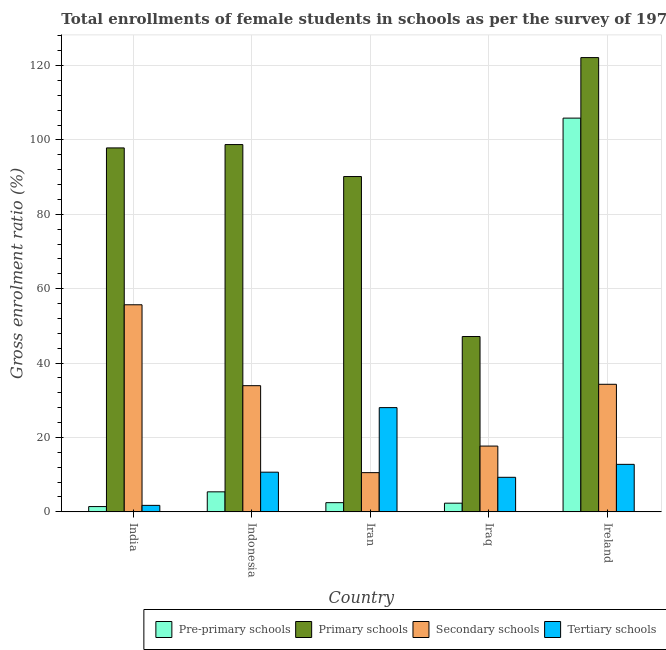How many different coloured bars are there?
Provide a short and direct response. 4. How many groups of bars are there?
Give a very brief answer. 5. Are the number of bars per tick equal to the number of legend labels?
Ensure brevity in your answer.  Yes. How many bars are there on the 2nd tick from the left?
Your response must be concise. 4. How many bars are there on the 2nd tick from the right?
Your answer should be compact. 4. What is the label of the 5th group of bars from the left?
Offer a very short reply. Ireland. What is the gross enrolment ratio(female) in tertiary schools in India?
Provide a short and direct response. 1.75. Across all countries, what is the maximum gross enrolment ratio(female) in primary schools?
Make the answer very short. 122.12. Across all countries, what is the minimum gross enrolment ratio(female) in primary schools?
Offer a terse response. 47.14. In which country was the gross enrolment ratio(female) in primary schools minimum?
Offer a very short reply. Iraq. What is the total gross enrolment ratio(female) in secondary schools in the graph?
Offer a very short reply. 152.13. What is the difference between the gross enrolment ratio(female) in secondary schools in Iran and that in Ireland?
Your answer should be very brief. -23.75. What is the difference between the gross enrolment ratio(female) in pre-primary schools in Iraq and the gross enrolment ratio(female) in primary schools in Ireland?
Your answer should be very brief. -119.78. What is the average gross enrolment ratio(female) in primary schools per country?
Offer a very short reply. 91.2. What is the difference between the gross enrolment ratio(female) in tertiary schools and gross enrolment ratio(female) in primary schools in India?
Provide a succinct answer. -96.09. What is the ratio of the gross enrolment ratio(female) in primary schools in India to that in Indonesia?
Give a very brief answer. 0.99. Is the gross enrolment ratio(female) in secondary schools in India less than that in Iraq?
Your answer should be very brief. No. Is the difference between the gross enrolment ratio(female) in pre-primary schools in India and Iran greater than the difference between the gross enrolment ratio(female) in primary schools in India and Iran?
Ensure brevity in your answer.  No. What is the difference between the highest and the second highest gross enrolment ratio(female) in primary schools?
Ensure brevity in your answer.  23.38. What is the difference between the highest and the lowest gross enrolment ratio(female) in primary schools?
Ensure brevity in your answer.  74.98. In how many countries, is the gross enrolment ratio(female) in secondary schools greater than the average gross enrolment ratio(female) in secondary schools taken over all countries?
Offer a very short reply. 3. Is the sum of the gross enrolment ratio(female) in tertiary schools in India and Iraq greater than the maximum gross enrolment ratio(female) in pre-primary schools across all countries?
Your answer should be compact. No. Is it the case that in every country, the sum of the gross enrolment ratio(female) in tertiary schools and gross enrolment ratio(female) in primary schools is greater than the sum of gross enrolment ratio(female) in secondary schools and gross enrolment ratio(female) in pre-primary schools?
Make the answer very short. No. What does the 2nd bar from the left in India represents?
Provide a short and direct response. Primary schools. What does the 2nd bar from the right in Indonesia represents?
Make the answer very short. Secondary schools. What is the difference between two consecutive major ticks on the Y-axis?
Offer a very short reply. 20. Are the values on the major ticks of Y-axis written in scientific E-notation?
Your answer should be very brief. No. Does the graph contain any zero values?
Provide a succinct answer. No. Does the graph contain grids?
Provide a succinct answer. Yes. Where does the legend appear in the graph?
Provide a succinct answer. Bottom right. How are the legend labels stacked?
Your answer should be compact. Horizontal. What is the title of the graph?
Ensure brevity in your answer.  Total enrollments of female students in schools as per the survey of 1973 conducted in different countries. What is the label or title of the X-axis?
Make the answer very short. Country. What is the label or title of the Y-axis?
Your answer should be compact. Gross enrolment ratio (%). What is the Gross enrolment ratio (%) of Pre-primary schools in India?
Keep it short and to the point. 1.43. What is the Gross enrolment ratio (%) of Primary schools in India?
Provide a succinct answer. 97.84. What is the Gross enrolment ratio (%) of Secondary schools in India?
Offer a terse response. 55.67. What is the Gross enrolment ratio (%) of Tertiary schools in India?
Provide a succinct answer. 1.75. What is the Gross enrolment ratio (%) in Pre-primary schools in Indonesia?
Ensure brevity in your answer.  5.39. What is the Gross enrolment ratio (%) in Primary schools in Indonesia?
Keep it short and to the point. 98.74. What is the Gross enrolment ratio (%) in Secondary schools in Indonesia?
Provide a succinct answer. 33.92. What is the Gross enrolment ratio (%) in Tertiary schools in Indonesia?
Your answer should be very brief. 10.67. What is the Gross enrolment ratio (%) in Pre-primary schools in Iran?
Ensure brevity in your answer.  2.48. What is the Gross enrolment ratio (%) of Primary schools in Iran?
Keep it short and to the point. 90.15. What is the Gross enrolment ratio (%) in Secondary schools in Iran?
Provide a succinct answer. 10.55. What is the Gross enrolment ratio (%) in Tertiary schools in Iran?
Provide a short and direct response. 28.03. What is the Gross enrolment ratio (%) in Pre-primary schools in Iraq?
Your answer should be very brief. 2.34. What is the Gross enrolment ratio (%) in Primary schools in Iraq?
Offer a very short reply. 47.14. What is the Gross enrolment ratio (%) in Secondary schools in Iraq?
Your response must be concise. 17.69. What is the Gross enrolment ratio (%) in Tertiary schools in Iraq?
Offer a terse response. 9.29. What is the Gross enrolment ratio (%) in Pre-primary schools in Ireland?
Your answer should be compact. 105.85. What is the Gross enrolment ratio (%) of Primary schools in Ireland?
Your answer should be compact. 122.12. What is the Gross enrolment ratio (%) of Secondary schools in Ireland?
Offer a very short reply. 34.3. What is the Gross enrolment ratio (%) in Tertiary schools in Ireland?
Your answer should be very brief. 12.77. Across all countries, what is the maximum Gross enrolment ratio (%) of Pre-primary schools?
Your answer should be very brief. 105.85. Across all countries, what is the maximum Gross enrolment ratio (%) of Primary schools?
Offer a terse response. 122.12. Across all countries, what is the maximum Gross enrolment ratio (%) in Secondary schools?
Ensure brevity in your answer.  55.67. Across all countries, what is the maximum Gross enrolment ratio (%) of Tertiary schools?
Provide a short and direct response. 28.03. Across all countries, what is the minimum Gross enrolment ratio (%) in Pre-primary schools?
Make the answer very short. 1.43. Across all countries, what is the minimum Gross enrolment ratio (%) of Primary schools?
Provide a short and direct response. 47.14. Across all countries, what is the minimum Gross enrolment ratio (%) of Secondary schools?
Your answer should be compact. 10.55. Across all countries, what is the minimum Gross enrolment ratio (%) of Tertiary schools?
Provide a short and direct response. 1.75. What is the total Gross enrolment ratio (%) in Pre-primary schools in the graph?
Provide a succinct answer. 117.48. What is the total Gross enrolment ratio (%) of Primary schools in the graph?
Ensure brevity in your answer.  455.99. What is the total Gross enrolment ratio (%) of Secondary schools in the graph?
Your response must be concise. 152.13. What is the total Gross enrolment ratio (%) in Tertiary schools in the graph?
Give a very brief answer. 62.51. What is the difference between the Gross enrolment ratio (%) in Pre-primary schools in India and that in Indonesia?
Your response must be concise. -3.96. What is the difference between the Gross enrolment ratio (%) in Primary schools in India and that in Indonesia?
Your response must be concise. -0.9. What is the difference between the Gross enrolment ratio (%) in Secondary schools in India and that in Indonesia?
Offer a terse response. 21.75. What is the difference between the Gross enrolment ratio (%) of Tertiary schools in India and that in Indonesia?
Your answer should be compact. -8.92. What is the difference between the Gross enrolment ratio (%) in Pre-primary schools in India and that in Iran?
Offer a very short reply. -1.05. What is the difference between the Gross enrolment ratio (%) of Primary schools in India and that in Iran?
Your response must be concise. 7.7. What is the difference between the Gross enrolment ratio (%) of Secondary schools in India and that in Iran?
Your answer should be very brief. 45.13. What is the difference between the Gross enrolment ratio (%) of Tertiary schools in India and that in Iran?
Ensure brevity in your answer.  -26.28. What is the difference between the Gross enrolment ratio (%) in Pre-primary schools in India and that in Iraq?
Offer a very short reply. -0.91. What is the difference between the Gross enrolment ratio (%) in Primary schools in India and that in Iraq?
Your response must be concise. 50.7. What is the difference between the Gross enrolment ratio (%) of Secondary schools in India and that in Iraq?
Your response must be concise. 37.99. What is the difference between the Gross enrolment ratio (%) in Tertiary schools in India and that in Iraq?
Offer a very short reply. -7.54. What is the difference between the Gross enrolment ratio (%) in Pre-primary schools in India and that in Ireland?
Provide a short and direct response. -104.42. What is the difference between the Gross enrolment ratio (%) of Primary schools in India and that in Ireland?
Ensure brevity in your answer.  -24.28. What is the difference between the Gross enrolment ratio (%) in Secondary schools in India and that in Ireland?
Keep it short and to the point. 21.38. What is the difference between the Gross enrolment ratio (%) in Tertiary schools in India and that in Ireland?
Your response must be concise. -11.02. What is the difference between the Gross enrolment ratio (%) of Pre-primary schools in Indonesia and that in Iran?
Make the answer very short. 2.91. What is the difference between the Gross enrolment ratio (%) of Primary schools in Indonesia and that in Iran?
Provide a short and direct response. 8.59. What is the difference between the Gross enrolment ratio (%) of Secondary schools in Indonesia and that in Iran?
Keep it short and to the point. 23.38. What is the difference between the Gross enrolment ratio (%) in Tertiary schools in Indonesia and that in Iran?
Offer a terse response. -17.36. What is the difference between the Gross enrolment ratio (%) in Pre-primary schools in Indonesia and that in Iraq?
Make the answer very short. 3.05. What is the difference between the Gross enrolment ratio (%) of Primary schools in Indonesia and that in Iraq?
Offer a very short reply. 51.6. What is the difference between the Gross enrolment ratio (%) of Secondary schools in Indonesia and that in Iraq?
Give a very brief answer. 16.23. What is the difference between the Gross enrolment ratio (%) of Tertiary schools in Indonesia and that in Iraq?
Provide a short and direct response. 1.38. What is the difference between the Gross enrolment ratio (%) of Pre-primary schools in Indonesia and that in Ireland?
Provide a succinct answer. -100.46. What is the difference between the Gross enrolment ratio (%) of Primary schools in Indonesia and that in Ireland?
Your response must be concise. -23.38. What is the difference between the Gross enrolment ratio (%) in Secondary schools in Indonesia and that in Ireland?
Your answer should be compact. -0.38. What is the difference between the Gross enrolment ratio (%) of Tertiary schools in Indonesia and that in Ireland?
Your answer should be very brief. -2.11. What is the difference between the Gross enrolment ratio (%) of Pre-primary schools in Iran and that in Iraq?
Make the answer very short. 0.14. What is the difference between the Gross enrolment ratio (%) of Primary schools in Iran and that in Iraq?
Make the answer very short. 43.01. What is the difference between the Gross enrolment ratio (%) of Secondary schools in Iran and that in Iraq?
Your response must be concise. -7.14. What is the difference between the Gross enrolment ratio (%) in Tertiary schools in Iran and that in Iraq?
Your response must be concise. 18.73. What is the difference between the Gross enrolment ratio (%) in Pre-primary schools in Iran and that in Ireland?
Ensure brevity in your answer.  -103.37. What is the difference between the Gross enrolment ratio (%) in Primary schools in Iran and that in Ireland?
Offer a very short reply. -31.98. What is the difference between the Gross enrolment ratio (%) of Secondary schools in Iran and that in Ireland?
Your answer should be compact. -23.75. What is the difference between the Gross enrolment ratio (%) in Tertiary schools in Iran and that in Ireland?
Your response must be concise. 15.25. What is the difference between the Gross enrolment ratio (%) in Pre-primary schools in Iraq and that in Ireland?
Offer a very short reply. -103.51. What is the difference between the Gross enrolment ratio (%) of Primary schools in Iraq and that in Ireland?
Ensure brevity in your answer.  -74.98. What is the difference between the Gross enrolment ratio (%) of Secondary schools in Iraq and that in Ireland?
Your response must be concise. -16.61. What is the difference between the Gross enrolment ratio (%) of Tertiary schools in Iraq and that in Ireland?
Make the answer very short. -3.48. What is the difference between the Gross enrolment ratio (%) of Pre-primary schools in India and the Gross enrolment ratio (%) of Primary schools in Indonesia?
Your answer should be very brief. -97.31. What is the difference between the Gross enrolment ratio (%) of Pre-primary schools in India and the Gross enrolment ratio (%) of Secondary schools in Indonesia?
Make the answer very short. -32.5. What is the difference between the Gross enrolment ratio (%) of Pre-primary schools in India and the Gross enrolment ratio (%) of Tertiary schools in Indonesia?
Make the answer very short. -9.24. What is the difference between the Gross enrolment ratio (%) in Primary schools in India and the Gross enrolment ratio (%) in Secondary schools in Indonesia?
Offer a very short reply. 63.92. What is the difference between the Gross enrolment ratio (%) of Primary schools in India and the Gross enrolment ratio (%) of Tertiary schools in Indonesia?
Your response must be concise. 87.17. What is the difference between the Gross enrolment ratio (%) of Secondary schools in India and the Gross enrolment ratio (%) of Tertiary schools in Indonesia?
Your answer should be compact. 45. What is the difference between the Gross enrolment ratio (%) of Pre-primary schools in India and the Gross enrolment ratio (%) of Primary schools in Iran?
Provide a succinct answer. -88.72. What is the difference between the Gross enrolment ratio (%) in Pre-primary schools in India and the Gross enrolment ratio (%) in Secondary schools in Iran?
Your answer should be compact. -9.12. What is the difference between the Gross enrolment ratio (%) of Pre-primary schools in India and the Gross enrolment ratio (%) of Tertiary schools in Iran?
Give a very brief answer. -26.6. What is the difference between the Gross enrolment ratio (%) of Primary schools in India and the Gross enrolment ratio (%) of Secondary schools in Iran?
Your answer should be very brief. 87.3. What is the difference between the Gross enrolment ratio (%) of Primary schools in India and the Gross enrolment ratio (%) of Tertiary schools in Iran?
Offer a very short reply. 69.82. What is the difference between the Gross enrolment ratio (%) in Secondary schools in India and the Gross enrolment ratio (%) in Tertiary schools in Iran?
Provide a succinct answer. 27.65. What is the difference between the Gross enrolment ratio (%) of Pre-primary schools in India and the Gross enrolment ratio (%) of Primary schools in Iraq?
Your response must be concise. -45.71. What is the difference between the Gross enrolment ratio (%) of Pre-primary schools in India and the Gross enrolment ratio (%) of Secondary schools in Iraq?
Keep it short and to the point. -16.26. What is the difference between the Gross enrolment ratio (%) of Pre-primary schools in India and the Gross enrolment ratio (%) of Tertiary schools in Iraq?
Keep it short and to the point. -7.87. What is the difference between the Gross enrolment ratio (%) in Primary schools in India and the Gross enrolment ratio (%) in Secondary schools in Iraq?
Provide a short and direct response. 80.16. What is the difference between the Gross enrolment ratio (%) in Primary schools in India and the Gross enrolment ratio (%) in Tertiary schools in Iraq?
Your answer should be very brief. 88.55. What is the difference between the Gross enrolment ratio (%) in Secondary schools in India and the Gross enrolment ratio (%) in Tertiary schools in Iraq?
Your answer should be very brief. 46.38. What is the difference between the Gross enrolment ratio (%) in Pre-primary schools in India and the Gross enrolment ratio (%) in Primary schools in Ireland?
Offer a very short reply. -120.7. What is the difference between the Gross enrolment ratio (%) in Pre-primary schools in India and the Gross enrolment ratio (%) in Secondary schools in Ireland?
Your answer should be very brief. -32.87. What is the difference between the Gross enrolment ratio (%) of Pre-primary schools in India and the Gross enrolment ratio (%) of Tertiary schools in Ireland?
Your response must be concise. -11.35. What is the difference between the Gross enrolment ratio (%) of Primary schools in India and the Gross enrolment ratio (%) of Secondary schools in Ireland?
Offer a very short reply. 63.55. What is the difference between the Gross enrolment ratio (%) in Primary schools in India and the Gross enrolment ratio (%) in Tertiary schools in Ireland?
Provide a succinct answer. 85.07. What is the difference between the Gross enrolment ratio (%) in Secondary schools in India and the Gross enrolment ratio (%) in Tertiary schools in Ireland?
Offer a very short reply. 42.9. What is the difference between the Gross enrolment ratio (%) in Pre-primary schools in Indonesia and the Gross enrolment ratio (%) in Primary schools in Iran?
Make the answer very short. -84.76. What is the difference between the Gross enrolment ratio (%) of Pre-primary schools in Indonesia and the Gross enrolment ratio (%) of Secondary schools in Iran?
Offer a terse response. -5.16. What is the difference between the Gross enrolment ratio (%) of Pre-primary schools in Indonesia and the Gross enrolment ratio (%) of Tertiary schools in Iran?
Ensure brevity in your answer.  -22.64. What is the difference between the Gross enrolment ratio (%) of Primary schools in Indonesia and the Gross enrolment ratio (%) of Secondary schools in Iran?
Your answer should be compact. 88.19. What is the difference between the Gross enrolment ratio (%) in Primary schools in Indonesia and the Gross enrolment ratio (%) in Tertiary schools in Iran?
Keep it short and to the point. 70.71. What is the difference between the Gross enrolment ratio (%) in Secondary schools in Indonesia and the Gross enrolment ratio (%) in Tertiary schools in Iran?
Your response must be concise. 5.9. What is the difference between the Gross enrolment ratio (%) in Pre-primary schools in Indonesia and the Gross enrolment ratio (%) in Primary schools in Iraq?
Offer a terse response. -41.75. What is the difference between the Gross enrolment ratio (%) of Pre-primary schools in Indonesia and the Gross enrolment ratio (%) of Secondary schools in Iraq?
Your response must be concise. -12.3. What is the difference between the Gross enrolment ratio (%) in Pre-primary schools in Indonesia and the Gross enrolment ratio (%) in Tertiary schools in Iraq?
Provide a succinct answer. -3.9. What is the difference between the Gross enrolment ratio (%) of Primary schools in Indonesia and the Gross enrolment ratio (%) of Secondary schools in Iraq?
Provide a succinct answer. 81.05. What is the difference between the Gross enrolment ratio (%) of Primary schools in Indonesia and the Gross enrolment ratio (%) of Tertiary schools in Iraq?
Ensure brevity in your answer.  89.45. What is the difference between the Gross enrolment ratio (%) in Secondary schools in Indonesia and the Gross enrolment ratio (%) in Tertiary schools in Iraq?
Provide a succinct answer. 24.63. What is the difference between the Gross enrolment ratio (%) of Pre-primary schools in Indonesia and the Gross enrolment ratio (%) of Primary schools in Ireland?
Provide a succinct answer. -116.74. What is the difference between the Gross enrolment ratio (%) of Pre-primary schools in Indonesia and the Gross enrolment ratio (%) of Secondary schools in Ireland?
Provide a succinct answer. -28.91. What is the difference between the Gross enrolment ratio (%) of Pre-primary schools in Indonesia and the Gross enrolment ratio (%) of Tertiary schools in Ireland?
Your answer should be very brief. -7.39. What is the difference between the Gross enrolment ratio (%) in Primary schools in Indonesia and the Gross enrolment ratio (%) in Secondary schools in Ireland?
Offer a terse response. 64.44. What is the difference between the Gross enrolment ratio (%) in Primary schools in Indonesia and the Gross enrolment ratio (%) in Tertiary schools in Ireland?
Offer a terse response. 85.97. What is the difference between the Gross enrolment ratio (%) of Secondary schools in Indonesia and the Gross enrolment ratio (%) of Tertiary schools in Ireland?
Provide a short and direct response. 21.15. What is the difference between the Gross enrolment ratio (%) in Pre-primary schools in Iran and the Gross enrolment ratio (%) in Primary schools in Iraq?
Your response must be concise. -44.66. What is the difference between the Gross enrolment ratio (%) of Pre-primary schools in Iran and the Gross enrolment ratio (%) of Secondary schools in Iraq?
Offer a very short reply. -15.21. What is the difference between the Gross enrolment ratio (%) of Pre-primary schools in Iran and the Gross enrolment ratio (%) of Tertiary schools in Iraq?
Provide a short and direct response. -6.81. What is the difference between the Gross enrolment ratio (%) of Primary schools in Iran and the Gross enrolment ratio (%) of Secondary schools in Iraq?
Give a very brief answer. 72.46. What is the difference between the Gross enrolment ratio (%) of Primary schools in Iran and the Gross enrolment ratio (%) of Tertiary schools in Iraq?
Give a very brief answer. 80.86. What is the difference between the Gross enrolment ratio (%) in Secondary schools in Iran and the Gross enrolment ratio (%) in Tertiary schools in Iraq?
Your response must be concise. 1.25. What is the difference between the Gross enrolment ratio (%) in Pre-primary schools in Iran and the Gross enrolment ratio (%) in Primary schools in Ireland?
Provide a short and direct response. -119.65. What is the difference between the Gross enrolment ratio (%) in Pre-primary schools in Iran and the Gross enrolment ratio (%) in Secondary schools in Ireland?
Offer a very short reply. -31.82. What is the difference between the Gross enrolment ratio (%) of Pre-primary schools in Iran and the Gross enrolment ratio (%) of Tertiary schools in Ireland?
Offer a very short reply. -10.3. What is the difference between the Gross enrolment ratio (%) of Primary schools in Iran and the Gross enrolment ratio (%) of Secondary schools in Ireland?
Keep it short and to the point. 55.85. What is the difference between the Gross enrolment ratio (%) of Primary schools in Iran and the Gross enrolment ratio (%) of Tertiary schools in Ireland?
Your answer should be very brief. 77.37. What is the difference between the Gross enrolment ratio (%) in Secondary schools in Iran and the Gross enrolment ratio (%) in Tertiary schools in Ireland?
Your answer should be compact. -2.23. What is the difference between the Gross enrolment ratio (%) in Pre-primary schools in Iraq and the Gross enrolment ratio (%) in Primary schools in Ireland?
Your answer should be very brief. -119.78. What is the difference between the Gross enrolment ratio (%) in Pre-primary schools in Iraq and the Gross enrolment ratio (%) in Secondary schools in Ireland?
Your answer should be very brief. -31.96. What is the difference between the Gross enrolment ratio (%) of Pre-primary schools in Iraq and the Gross enrolment ratio (%) of Tertiary schools in Ireland?
Keep it short and to the point. -10.44. What is the difference between the Gross enrolment ratio (%) in Primary schools in Iraq and the Gross enrolment ratio (%) in Secondary schools in Ireland?
Offer a very short reply. 12.84. What is the difference between the Gross enrolment ratio (%) in Primary schools in Iraq and the Gross enrolment ratio (%) in Tertiary schools in Ireland?
Your answer should be very brief. 34.37. What is the difference between the Gross enrolment ratio (%) of Secondary schools in Iraq and the Gross enrolment ratio (%) of Tertiary schools in Ireland?
Keep it short and to the point. 4.91. What is the average Gross enrolment ratio (%) of Pre-primary schools per country?
Your response must be concise. 23.5. What is the average Gross enrolment ratio (%) in Primary schools per country?
Provide a short and direct response. 91.2. What is the average Gross enrolment ratio (%) in Secondary schools per country?
Give a very brief answer. 30.43. What is the average Gross enrolment ratio (%) in Tertiary schools per country?
Provide a short and direct response. 12.5. What is the difference between the Gross enrolment ratio (%) in Pre-primary schools and Gross enrolment ratio (%) in Primary schools in India?
Provide a short and direct response. -96.42. What is the difference between the Gross enrolment ratio (%) of Pre-primary schools and Gross enrolment ratio (%) of Secondary schools in India?
Ensure brevity in your answer.  -54.25. What is the difference between the Gross enrolment ratio (%) in Pre-primary schools and Gross enrolment ratio (%) in Tertiary schools in India?
Keep it short and to the point. -0.33. What is the difference between the Gross enrolment ratio (%) of Primary schools and Gross enrolment ratio (%) of Secondary schools in India?
Your answer should be compact. 42.17. What is the difference between the Gross enrolment ratio (%) of Primary schools and Gross enrolment ratio (%) of Tertiary schools in India?
Keep it short and to the point. 96.09. What is the difference between the Gross enrolment ratio (%) of Secondary schools and Gross enrolment ratio (%) of Tertiary schools in India?
Your answer should be compact. 53.92. What is the difference between the Gross enrolment ratio (%) in Pre-primary schools and Gross enrolment ratio (%) in Primary schools in Indonesia?
Keep it short and to the point. -93.35. What is the difference between the Gross enrolment ratio (%) in Pre-primary schools and Gross enrolment ratio (%) in Secondary schools in Indonesia?
Give a very brief answer. -28.54. What is the difference between the Gross enrolment ratio (%) of Pre-primary schools and Gross enrolment ratio (%) of Tertiary schools in Indonesia?
Make the answer very short. -5.28. What is the difference between the Gross enrolment ratio (%) of Primary schools and Gross enrolment ratio (%) of Secondary schools in Indonesia?
Offer a terse response. 64.82. What is the difference between the Gross enrolment ratio (%) of Primary schools and Gross enrolment ratio (%) of Tertiary schools in Indonesia?
Your response must be concise. 88.07. What is the difference between the Gross enrolment ratio (%) in Secondary schools and Gross enrolment ratio (%) in Tertiary schools in Indonesia?
Keep it short and to the point. 23.25. What is the difference between the Gross enrolment ratio (%) of Pre-primary schools and Gross enrolment ratio (%) of Primary schools in Iran?
Make the answer very short. -87.67. What is the difference between the Gross enrolment ratio (%) in Pre-primary schools and Gross enrolment ratio (%) in Secondary schools in Iran?
Keep it short and to the point. -8.07. What is the difference between the Gross enrolment ratio (%) of Pre-primary schools and Gross enrolment ratio (%) of Tertiary schools in Iran?
Ensure brevity in your answer.  -25.55. What is the difference between the Gross enrolment ratio (%) in Primary schools and Gross enrolment ratio (%) in Secondary schools in Iran?
Give a very brief answer. 79.6. What is the difference between the Gross enrolment ratio (%) of Primary schools and Gross enrolment ratio (%) of Tertiary schools in Iran?
Make the answer very short. 62.12. What is the difference between the Gross enrolment ratio (%) in Secondary schools and Gross enrolment ratio (%) in Tertiary schools in Iran?
Offer a terse response. -17.48. What is the difference between the Gross enrolment ratio (%) in Pre-primary schools and Gross enrolment ratio (%) in Primary schools in Iraq?
Provide a short and direct response. -44.8. What is the difference between the Gross enrolment ratio (%) in Pre-primary schools and Gross enrolment ratio (%) in Secondary schools in Iraq?
Keep it short and to the point. -15.35. What is the difference between the Gross enrolment ratio (%) of Pre-primary schools and Gross enrolment ratio (%) of Tertiary schools in Iraq?
Provide a short and direct response. -6.95. What is the difference between the Gross enrolment ratio (%) of Primary schools and Gross enrolment ratio (%) of Secondary schools in Iraq?
Provide a short and direct response. 29.45. What is the difference between the Gross enrolment ratio (%) in Primary schools and Gross enrolment ratio (%) in Tertiary schools in Iraq?
Make the answer very short. 37.85. What is the difference between the Gross enrolment ratio (%) in Secondary schools and Gross enrolment ratio (%) in Tertiary schools in Iraq?
Your answer should be very brief. 8.4. What is the difference between the Gross enrolment ratio (%) in Pre-primary schools and Gross enrolment ratio (%) in Primary schools in Ireland?
Keep it short and to the point. -16.27. What is the difference between the Gross enrolment ratio (%) of Pre-primary schools and Gross enrolment ratio (%) of Secondary schools in Ireland?
Keep it short and to the point. 71.55. What is the difference between the Gross enrolment ratio (%) in Pre-primary schools and Gross enrolment ratio (%) in Tertiary schools in Ireland?
Your answer should be compact. 93.08. What is the difference between the Gross enrolment ratio (%) of Primary schools and Gross enrolment ratio (%) of Secondary schools in Ireland?
Provide a short and direct response. 87.83. What is the difference between the Gross enrolment ratio (%) in Primary schools and Gross enrolment ratio (%) in Tertiary schools in Ireland?
Offer a terse response. 109.35. What is the difference between the Gross enrolment ratio (%) in Secondary schools and Gross enrolment ratio (%) in Tertiary schools in Ireland?
Make the answer very short. 21.52. What is the ratio of the Gross enrolment ratio (%) of Pre-primary schools in India to that in Indonesia?
Your response must be concise. 0.26. What is the ratio of the Gross enrolment ratio (%) of Primary schools in India to that in Indonesia?
Keep it short and to the point. 0.99. What is the ratio of the Gross enrolment ratio (%) of Secondary schools in India to that in Indonesia?
Keep it short and to the point. 1.64. What is the ratio of the Gross enrolment ratio (%) of Tertiary schools in India to that in Indonesia?
Provide a succinct answer. 0.16. What is the ratio of the Gross enrolment ratio (%) of Pre-primary schools in India to that in Iran?
Your answer should be compact. 0.58. What is the ratio of the Gross enrolment ratio (%) of Primary schools in India to that in Iran?
Your response must be concise. 1.09. What is the ratio of the Gross enrolment ratio (%) in Secondary schools in India to that in Iran?
Make the answer very short. 5.28. What is the ratio of the Gross enrolment ratio (%) of Tertiary schools in India to that in Iran?
Provide a succinct answer. 0.06. What is the ratio of the Gross enrolment ratio (%) of Pre-primary schools in India to that in Iraq?
Ensure brevity in your answer.  0.61. What is the ratio of the Gross enrolment ratio (%) in Primary schools in India to that in Iraq?
Give a very brief answer. 2.08. What is the ratio of the Gross enrolment ratio (%) in Secondary schools in India to that in Iraq?
Provide a short and direct response. 3.15. What is the ratio of the Gross enrolment ratio (%) of Tertiary schools in India to that in Iraq?
Give a very brief answer. 0.19. What is the ratio of the Gross enrolment ratio (%) of Pre-primary schools in India to that in Ireland?
Provide a short and direct response. 0.01. What is the ratio of the Gross enrolment ratio (%) of Primary schools in India to that in Ireland?
Keep it short and to the point. 0.8. What is the ratio of the Gross enrolment ratio (%) of Secondary schools in India to that in Ireland?
Provide a succinct answer. 1.62. What is the ratio of the Gross enrolment ratio (%) in Tertiary schools in India to that in Ireland?
Give a very brief answer. 0.14. What is the ratio of the Gross enrolment ratio (%) of Pre-primary schools in Indonesia to that in Iran?
Make the answer very short. 2.17. What is the ratio of the Gross enrolment ratio (%) in Primary schools in Indonesia to that in Iran?
Ensure brevity in your answer.  1.1. What is the ratio of the Gross enrolment ratio (%) in Secondary schools in Indonesia to that in Iran?
Keep it short and to the point. 3.22. What is the ratio of the Gross enrolment ratio (%) of Tertiary schools in Indonesia to that in Iran?
Make the answer very short. 0.38. What is the ratio of the Gross enrolment ratio (%) in Pre-primary schools in Indonesia to that in Iraq?
Provide a succinct answer. 2.3. What is the ratio of the Gross enrolment ratio (%) in Primary schools in Indonesia to that in Iraq?
Provide a succinct answer. 2.09. What is the ratio of the Gross enrolment ratio (%) in Secondary schools in Indonesia to that in Iraq?
Provide a succinct answer. 1.92. What is the ratio of the Gross enrolment ratio (%) of Tertiary schools in Indonesia to that in Iraq?
Keep it short and to the point. 1.15. What is the ratio of the Gross enrolment ratio (%) in Pre-primary schools in Indonesia to that in Ireland?
Ensure brevity in your answer.  0.05. What is the ratio of the Gross enrolment ratio (%) in Primary schools in Indonesia to that in Ireland?
Provide a succinct answer. 0.81. What is the ratio of the Gross enrolment ratio (%) of Tertiary schools in Indonesia to that in Ireland?
Make the answer very short. 0.84. What is the ratio of the Gross enrolment ratio (%) in Pre-primary schools in Iran to that in Iraq?
Your response must be concise. 1.06. What is the ratio of the Gross enrolment ratio (%) of Primary schools in Iran to that in Iraq?
Ensure brevity in your answer.  1.91. What is the ratio of the Gross enrolment ratio (%) in Secondary schools in Iran to that in Iraq?
Provide a succinct answer. 0.6. What is the ratio of the Gross enrolment ratio (%) of Tertiary schools in Iran to that in Iraq?
Give a very brief answer. 3.02. What is the ratio of the Gross enrolment ratio (%) of Pre-primary schools in Iran to that in Ireland?
Provide a succinct answer. 0.02. What is the ratio of the Gross enrolment ratio (%) of Primary schools in Iran to that in Ireland?
Provide a short and direct response. 0.74. What is the ratio of the Gross enrolment ratio (%) of Secondary schools in Iran to that in Ireland?
Your answer should be compact. 0.31. What is the ratio of the Gross enrolment ratio (%) of Tertiary schools in Iran to that in Ireland?
Give a very brief answer. 2.19. What is the ratio of the Gross enrolment ratio (%) in Pre-primary schools in Iraq to that in Ireland?
Keep it short and to the point. 0.02. What is the ratio of the Gross enrolment ratio (%) of Primary schools in Iraq to that in Ireland?
Provide a short and direct response. 0.39. What is the ratio of the Gross enrolment ratio (%) in Secondary schools in Iraq to that in Ireland?
Offer a very short reply. 0.52. What is the ratio of the Gross enrolment ratio (%) of Tertiary schools in Iraq to that in Ireland?
Offer a terse response. 0.73. What is the difference between the highest and the second highest Gross enrolment ratio (%) in Pre-primary schools?
Offer a very short reply. 100.46. What is the difference between the highest and the second highest Gross enrolment ratio (%) of Primary schools?
Offer a terse response. 23.38. What is the difference between the highest and the second highest Gross enrolment ratio (%) in Secondary schools?
Your answer should be very brief. 21.38. What is the difference between the highest and the second highest Gross enrolment ratio (%) in Tertiary schools?
Provide a short and direct response. 15.25. What is the difference between the highest and the lowest Gross enrolment ratio (%) in Pre-primary schools?
Your answer should be compact. 104.42. What is the difference between the highest and the lowest Gross enrolment ratio (%) of Primary schools?
Provide a short and direct response. 74.98. What is the difference between the highest and the lowest Gross enrolment ratio (%) of Secondary schools?
Make the answer very short. 45.13. What is the difference between the highest and the lowest Gross enrolment ratio (%) of Tertiary schools?
Your answer should be compact. 26.28. 